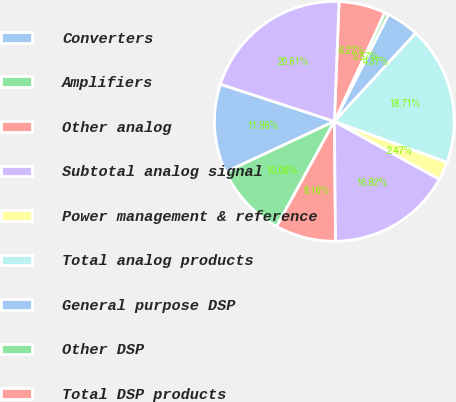<chart> <loc_0><loc_0><loc_500><loc_500><pie_chart><fcel>Converters<fcel>Amplifiers<fcel>Other analog<fcel>Subtotal analog signal<fcel>Power management & reference<fcel>Total analog products<fcel>General purpose DSP<fcel>Other DSP<fcel>Total DSP products<fcel>Total Product Revenue<nl><fcel>11.96%<fcel>10.06%<fcel>8.16%<fcel>16.82%<fcel>2.47%<fcel>18.71%<fcel>4.37%<fcel>0.57%<fcel>6.27%<fcel>20.61%<nl></chart> 